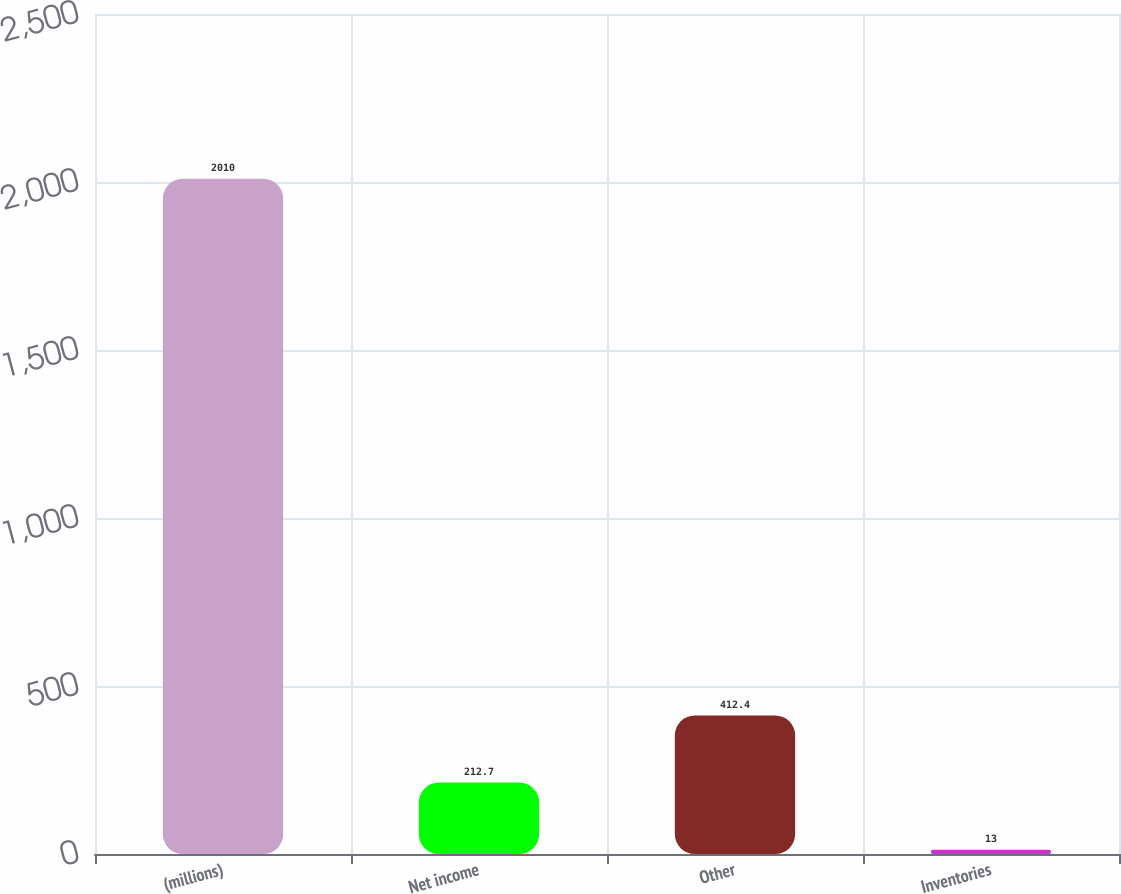<chart> <loc_0><loc_0><loc_500><loc_500><bar_chart><fcel>(millions)<fcel>Net income<fcel>Other<fcel>Inventories<nl><fcel>2010<fcel>212.7<fcel>412.4<fcel>13<nl></chart> 